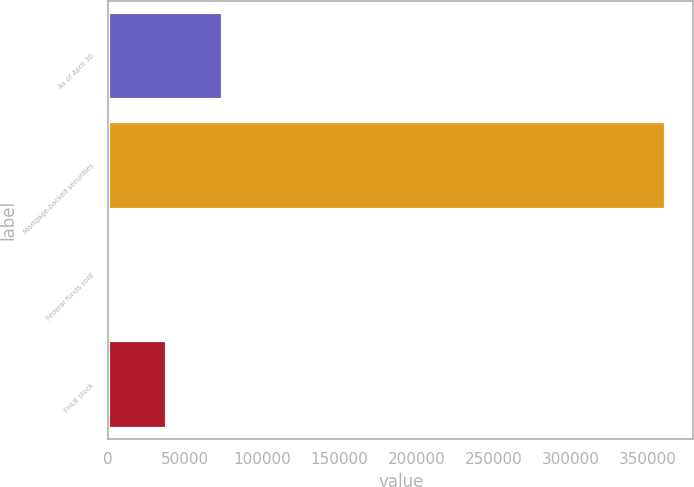Convert chart. <chart><loc_0><loc_0><loc_500><loc_500><bar_chart><fcel>As of April 30<fcel>Mortgage-backed securities<fcel>Federal funds sold<fcel>FHLB stock<nl><fcel>73505.6<fcel>361184<fcel>1586<fcel>37545.8<nl></chart> 